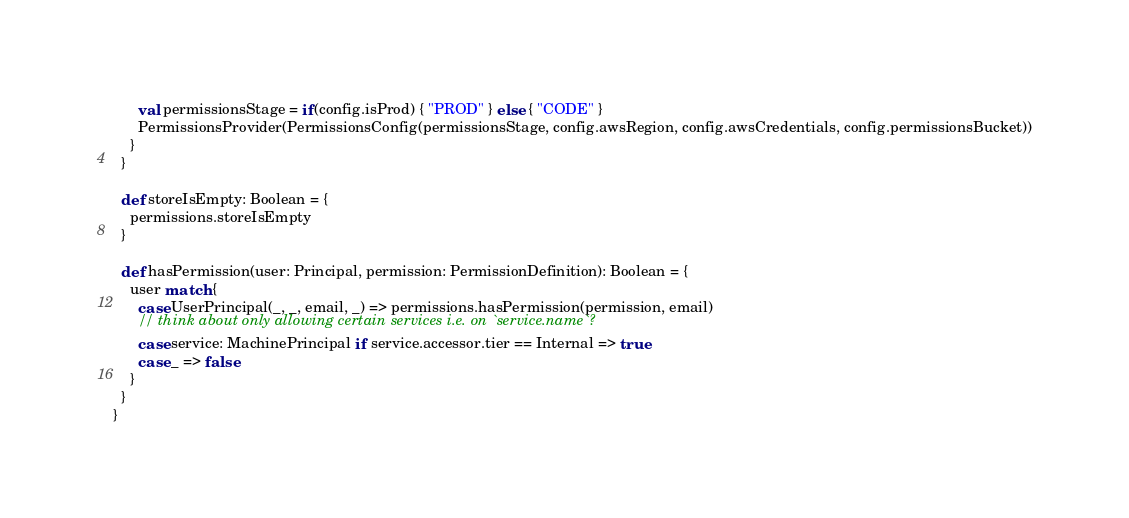<code> <loc_0><loc_0><loc_500><loc_500><_Scala_>      val permissionsStage = if(config.isProd) { "PROD" } else { "CODE" }
      PermissionsProvider(PermissionsConfig(permissionsStage, config.awsRegion, config.awsCredentials, config.permissionsBucket))
    }
  }

  def storeIsEmpty: Boolean = {
    permissions.storeIsEmpty
  }

  def hasPermission(user: Principal, permission: PermissionDefinition): Boolean = {
    user match {
      case UserPrincipal(_, _, email, _) => permissions.hasPermission(permission, email)
      // think about only allowing certain services i.e. on `service.name`?
      case service: MachinePrincipal if service.accessor.tier == Internal => true
      case _ => false
    }
  }
}
</code> 